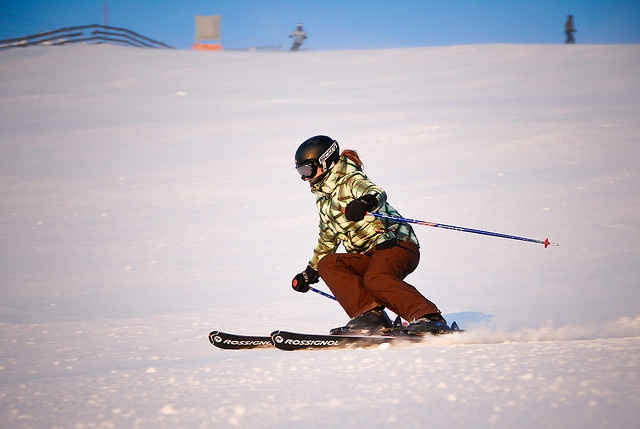Describe the objects in this image and their specific colors. I can see people in blue, maroon, black, ivory, and khaki tones, skis in blue, black, white, gray, and tan tones, people in blue and gray tones, and people in blue, darkgray, and gray tones in this image. 